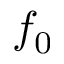Convert formula to latex. <formula><loc_0><loc_0><loc_500><loc_500>f _ { 0 }</formula> 